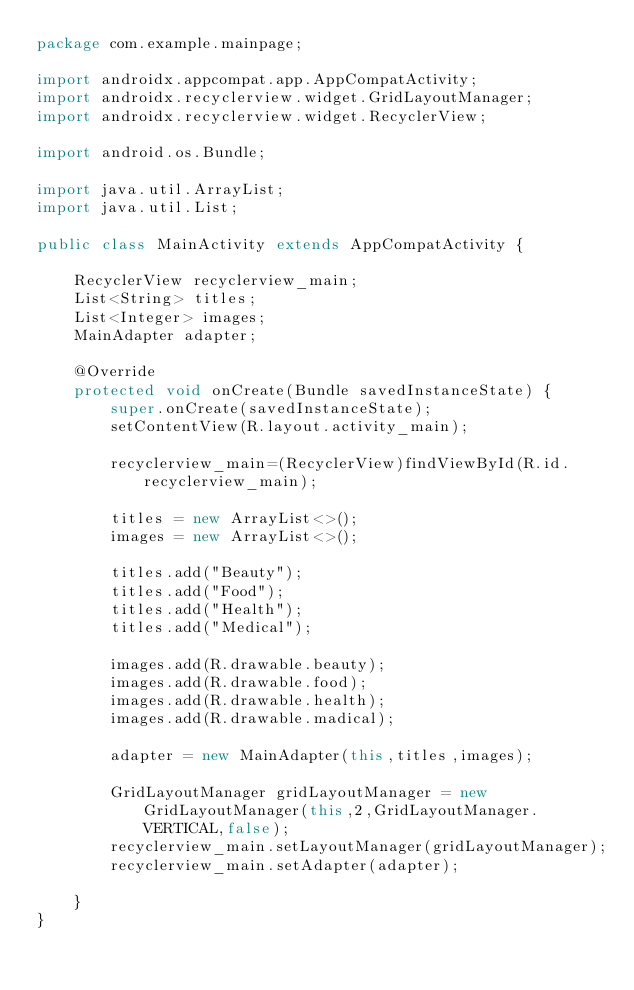<code> <loc_0><loc_0><loc_500><loc_500><_Java_>package com.example.mainpage;

import androidx.appcompat.app.AppCompatActivity;
import androidx.recyclerview.widget.GridLayoutManager;
import androidx.recyclerview.widget.RecyclerView;

import android.os.Bundle;

import java.util.ArrayList;
import java.util.List;

public class MainActivity extends AppCompatActivity {

    RecyclerView recyclerview_main;
    List<String> titles;
    List<Integer> images;
    MainAdapter adapter;

    @Override
    protected void onCreate(Bundle savedInstanceState) {
        super.onCreate(savedInstanceState);
        setContentView(R.layout.activity_main);

        recyclerview_main=(RecyclerView)findViewById(R.id.recyclerview_main);

        titles = new ArrayList<>();
        images = new ArrayList<>();

        titles.add("Beauty");
        titles.add("Food");
        titles.add("Health");
        titles.add("Medical");

        images.add(R.drawable.beauty);
        images.add(R.drawable.food);
        images.add(R.drawable.health);
        images.add(R.drawable.madical);

        adapter = new MainAdapter(this,titles,images);

        GridLayoutManager gridLayoutManager = new GridLayoutManager(this,2,GridLayoutManager.VERTICAL,false);
        recyclerview_main.setLayoutManager(gridLayoutManager);
        recyclerview_main.setAdapter(adapter);

    }
}</code> 